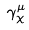<formula> <loc_0><loc_0><loc_500><loc_500>\gamma _ { \chi } ^ { \mu }</formula> 